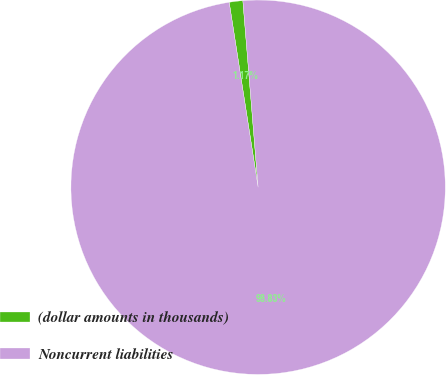<chart> <loc_0><loc_0><loc_500><loc_500><pie_chart><fcel>(dollar amounts in thousands)<fcel>Noncurrent liabilities<nl><fcel>1.17%<fcel>98.83%<nl></chart> 